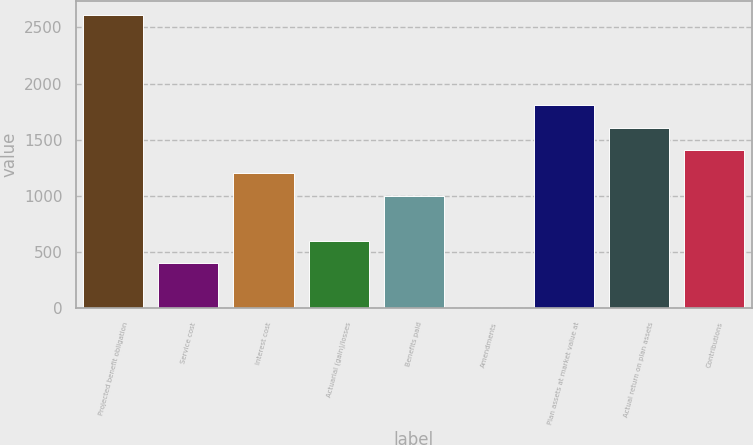Convert chart to OTSL. <chart><loc_0><loc_0><loc_500><loc_500><bar_chart><fcel>Projected benefit obligation<fcel>Service cost<fcel>Interest cost<fcel>Actuarial (gain)/losses<fcel>Benefits paid<fcel>Amendments<fcel>Plan assets at market value at<fcel>Actual return on plan assets<fcel>Contributions<nl><fcel>2607.2<fcel>402.8<fcel>1204.4<fcel>603.2<fcel>1004<fcel>2<fcel>1805.6<fcel>1605.2<fcel>1404.8<nl></chart> 